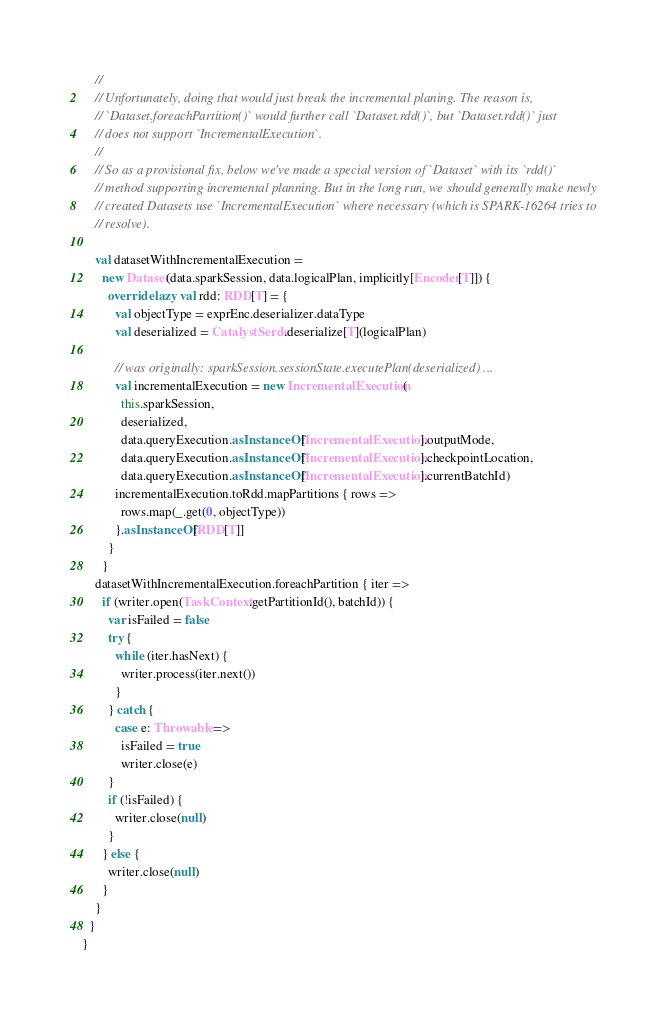<code> <loc_0><loc_0><loc_500><loc_500><_Scala_>    //
    // Unfortunately, doing that would just break the incremental planing. The reason is,
    // `Dataset.foreachPartition()` would further call `Dataset.rdd()`, but `Dataset.rdd()` just
    // does not support `IncrementalExecution`.
    //
    // So as a provisional fix, below we've made a special version of `Dataset` with its `rdd()`
    // method supporting incremental planning. But in the long run, we should generally make newly
    // created Datasets use `IncrementalExecution` where necessary (which is SPARK-16264 tries to
    // resolve).

    val datasetWithIncrementalExecution =
      new Dataset(data.sparkSession, data.logicalPlan, implicitly[Encoder[T]]) {
        override lazy val rdd: RDD[T] = {
          val objectType = exprEnc.deserializer.dataType
          val deserialized = CatalystSerde.deserialize[T](logicalPlan)

          // was originally: sparkSession.sessionState.executePlan(deserialized) ...
          val incrementalExecution = new IncrementalExecution(
            this.sparkSession,
            deserialized,
            data.queryExecution.asInstanceOf[IncrementalExecution].outputMode,
            data.queryExecution.asInstanceOf[IncrementalExecution].checkpointLocation,
            data.queryExecution.asInstanceOf[IncrementalExecution].currentBatchId)
          incrementalExecution.toRdd.mapPartitions { rows =>
            rows.map(_.get(0, objectType))
          }.asInstanceOf[RDD[T]]
        }
      }
    datasetWithIncrementalExecution.foreachPartition { iter =>
      if (writer.open(TaskContext.getPartitionId(), batchId)) {
        var isFailed = false
        try {
          while (iter.hasNext) {
            writer.process(iter.next())
          }
        } catch {
          case e: Throwable =>
            isFailed = true
            writer.close(e)
        }
        if (!isFailed) {
          writer.close(null)
        }
      } else {
        writer.close(null)
      }
    }
  }
}
</code> 